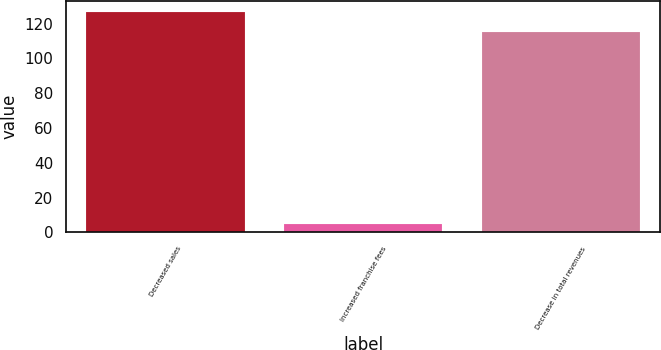<chart> <loc_0><loc_0><loc_500><loc_500><bar_chart><fcel>Decreased sales<fcel>Increased franchise fees<fcel>Decrease in total revenues<nl><fcel>126.5<fcel>5<fcel>115<nl></chart> 